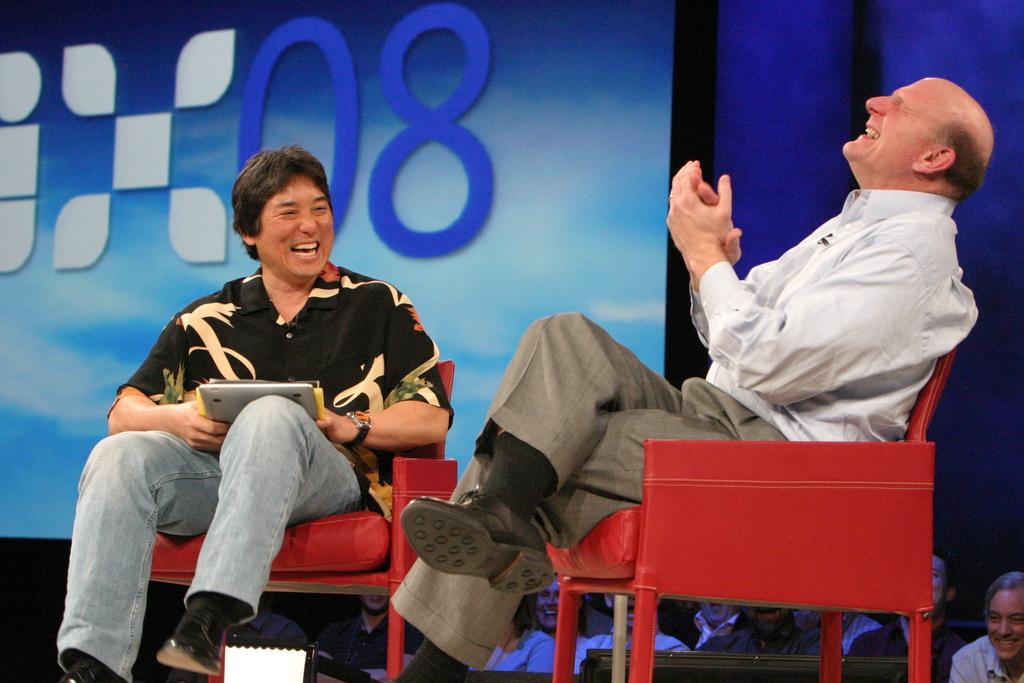How would you summarize this image in a sentence or two? In this picture there are two men sitting on a chair. The left side man is holding a tablet in his hands. The right side guy who is laughing loudly. In the background there is a screen which displays 08. There are few people in the background who are sitting on the floor. 